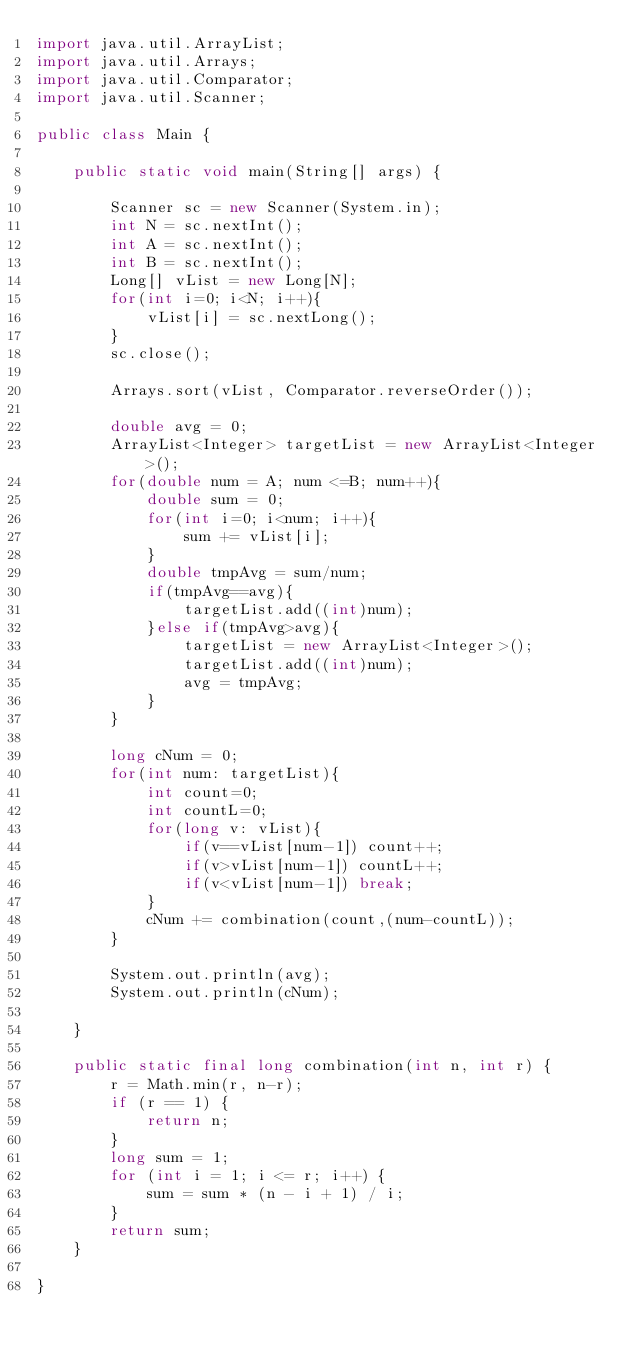Convert code to text. <code><loc_0><loc_0><loc_500><loc_500><_Java_>import java.util.ArrayList;
import java.util.Arrays;
import java.util.Comparator;
import java.util.Scanner;

public class Main {

	public static void main(String[] args) {
		
		Scanner sc = new Scanner(System.in);
		int N = sc.nextInt();
		int A = sc.nextInt();
		int B = sc.nextInt();
		Long[] vList = new Long[N];
		for(int i=0; i<N; i++){
			vList[i] = sc.nextLong();
		}
		sc.close();
		
		Arrays.sort(vList, Comparator.reverseOrder());
		
		double avg = 0;
		ArrayList<Integer> targetList = new ArrayList<Integer>();
		for(double num = A; num <=B; num++){
			double sum = 0;
			for(int i=0; i<num; i++){
				sum += vList[i];
			}
			double tmpAvg = sum/num;
			if(tmpAvg==avg){
				targetList.add((int)num);		
			}else if(tmpAvg>avg){
				targetList = new ArrayList<Integer>();
				targetList.add((int)num);
				avg = tmpAvg;
			}
		}
	
		long cNum = 0;
		for(int num: targetList){
			int count=0;
			int countL=0;
			for(long v: vList){
				if(v==vList[num-1]) count++;
				if(v>vList[num-1]) countL++;
				if(v<vList[num-1]) break;
			}
			cNum += combination(count,(num-countL));
		}
		
		System.out.println(avg);
		System.out.println(cNum);

	}
	
	public static final long combination(int n, int r) {
	    r = Math.min(r, n-r);
	    if (r == 1) {
	        return n;
	    }
	    long sum = 1;
	    for (int i = 1; i <= r; i++) {
	    	sum = sum * (n - i + 1) / i;
	    }
	    return sum;
	}

}</code> 